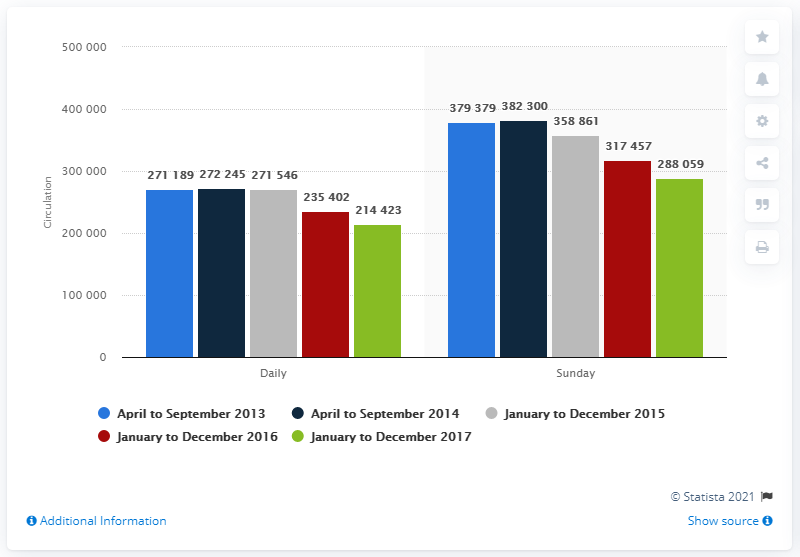Mention a couple of crucial points in this snapshot. As of December 2017, the daily circulation of the Dallas Morning News was approximately 214,423 copies. Has the daily circulation ever exceeded 300,000? The total annual Sunday circulation for the years 2016 and 2017 was 605,516. 